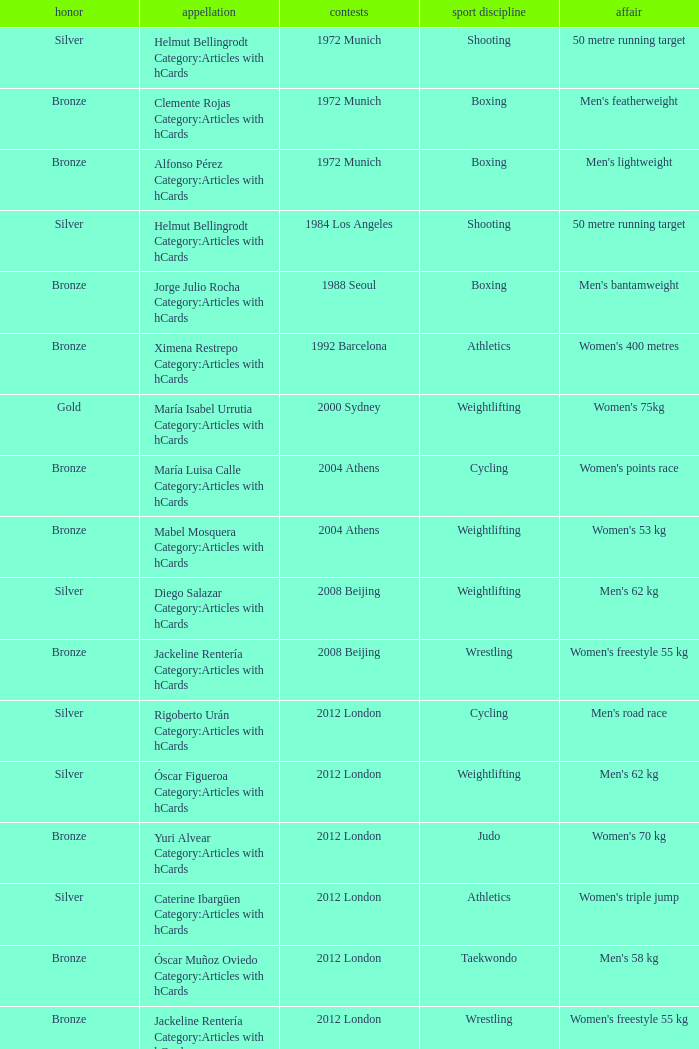Which sport resulted in a gold medal in the 2000 Sydney games? Weightlifting. 